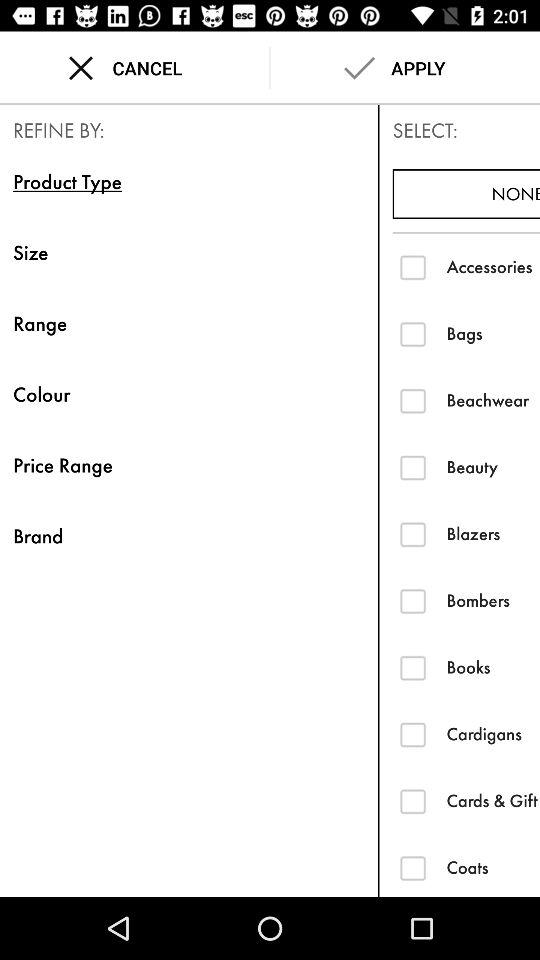Which option is selected in "REFINE BY"? The selected option is "Product Type". 